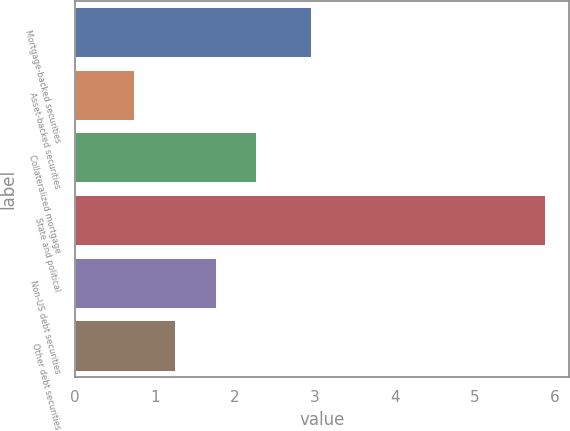Convert chart to OTSL. <chart><loc_0><loc_0><loc_500><loc_500><bar_chart><fcel>Mortgage-backed securities<fcel>Asset-backed securities<fcel>Collateralized mortgage<fcel>State and political<fcel>Non-US debt securities<fcel>Other debt securities<nl><fcel>2.95<fcel>0.74<fcel>2.27<fcel>5.88<fcel>1.76<fcel>1.25<nl></chart> 